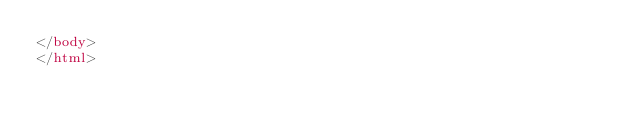Convert code to text. <code><loc_0><loc_0><loc_500><loc_500><_HTML_></body>
</html></code> 